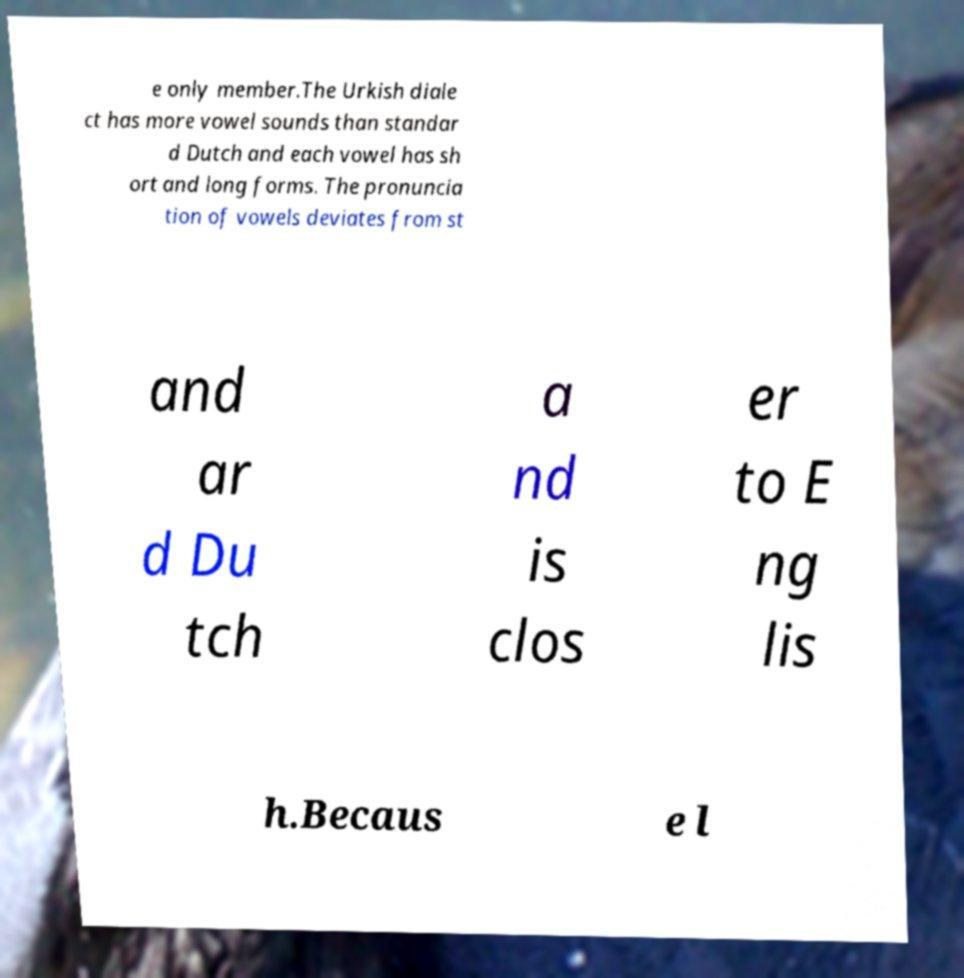What messages or text are displayed in this image? I need them in a readable, typed format. e only member.The Urkish diale ct has more vowel sounds than standar d Dutch and each vowel has sh ort and long forms. The pronuncia tion of vowels deviates from st and ar d Du tch a nd is clos er to E ng lis h.Becaus e l 